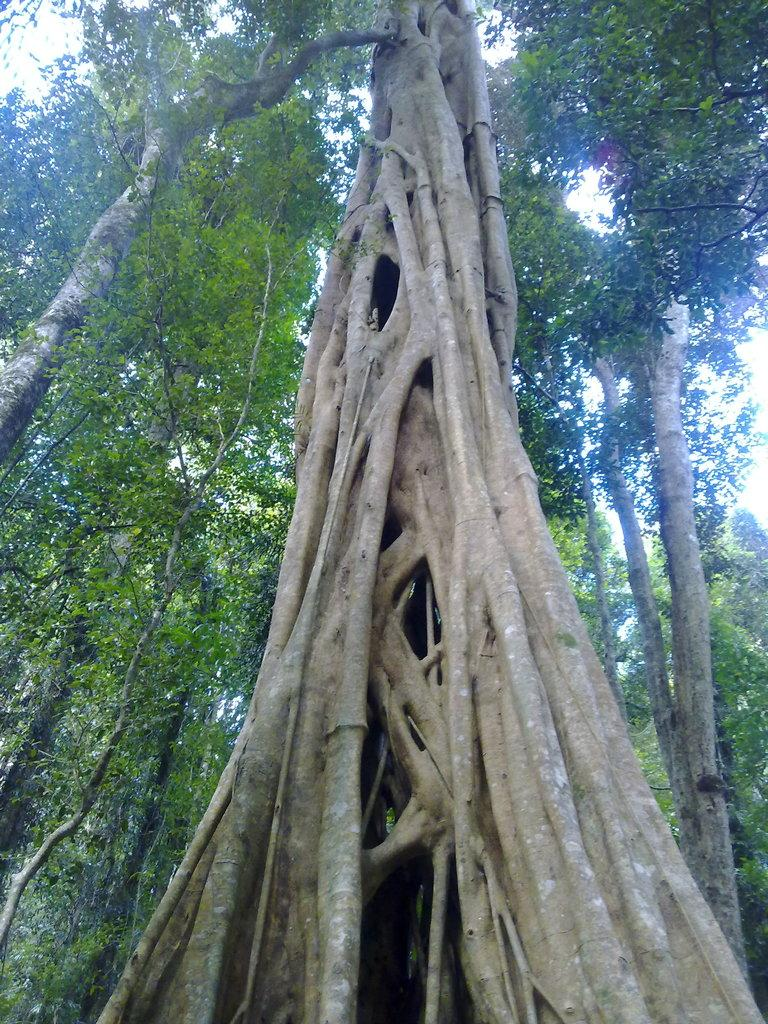What is the main subject in the foreground of the image? There is a tree trunk in the image. What can be seen in the background of the image? There are trees in the background of the image. What part of the natural environment is visible in the image? The sky is visible in the image. What type of field can be seen in the image? There is no field present in the image; it features a tree trunk and trees in the background. 